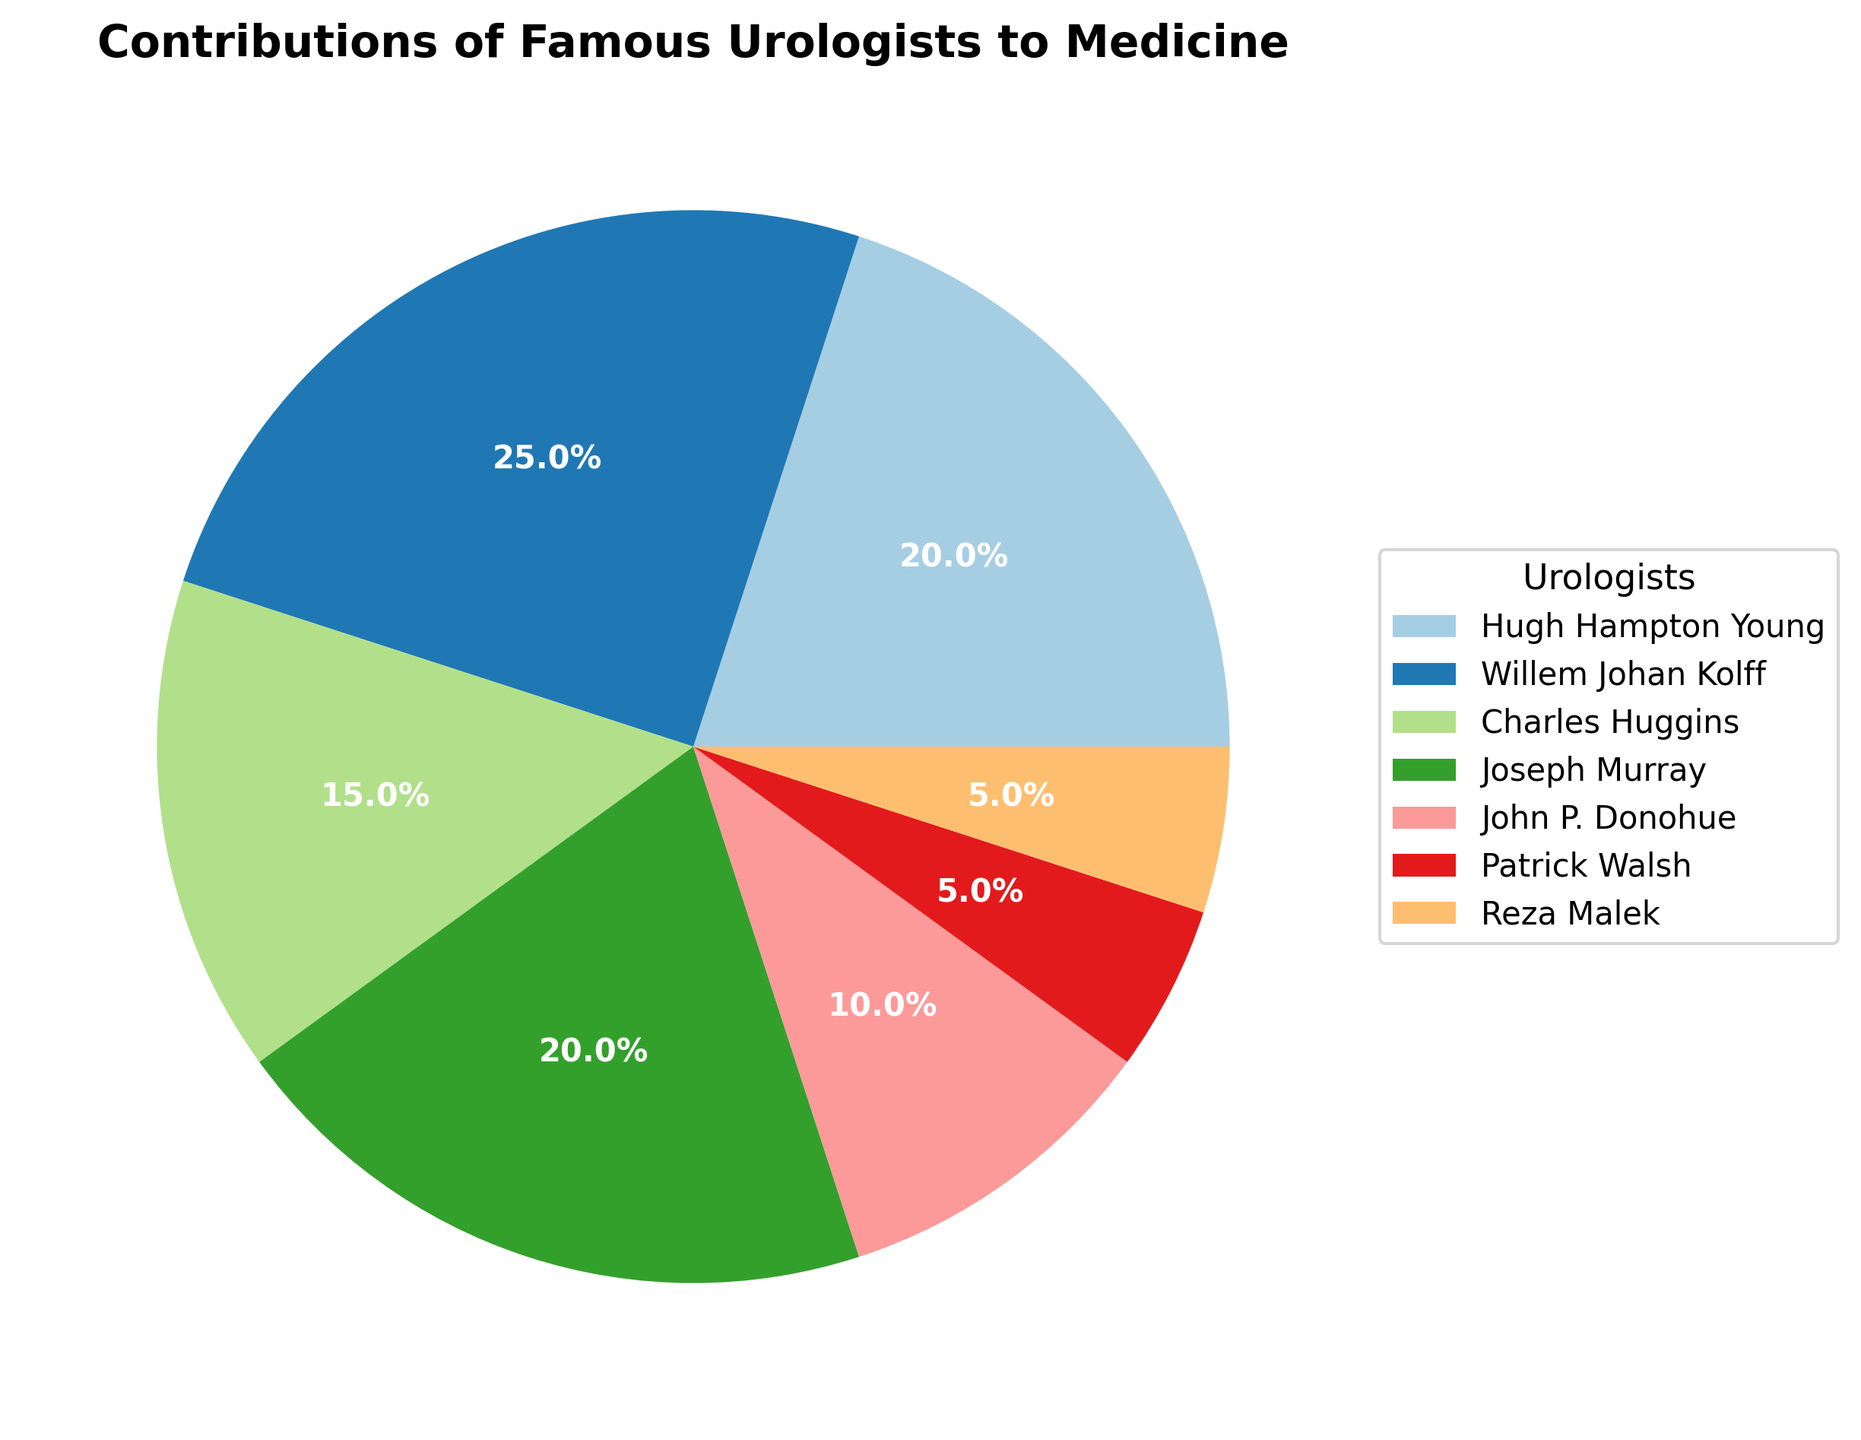What is the total percentage contribution of Hugh Hampton Young and Joseph Murray? To find the total percentage contribution, add the individual contributions of Hugh Hampton Young and Joseph Murray. Hugh Hampton Young's contribution is 20%, and Joseph Murray's contribution is also 20%. Adding them together gives 20% + 20% = 40%.
Answer: 40% Which urologist has made a greater contribution to medicine, Charles Huggins or John P. Donohue? Compare the percentages of contributions by Charles Huggins and John P. Donohue. Charles Huggins has a 15% contribution, while John P. Donohue has a 10% contribution. Since 15% is greater than 10%, Charles Huggins has made a greater contribution.
Answer: Charles Huggins What is the total contribution percentage of the urologists who worked on prostate surgery innovations and nerve-sparing prostatectomy? Add the percentages of contributions by Hugh Hampton Young (prostate surgery innovations) and Patrick Walsh (nerve-sparing prostatectomy). Hugh Hampton Young's contribution is 20%, and Patrick Walsh's is 5%. Therefore, the total contribution is 20% + 5% = 25%.
Answer: 25% Who has contributed more to medicine according to the pie chart, Willem Johan Kolff or the combined contributions of Patrick Walsh and Reza Malek? First, find the combined contributions of Patrick Walsh and Reza Malek, which are 5% + 5% = 10%. Compare this with Willem Johan Kolff's contribution, which is 25%. Since 25% is greater than 10%, Willem Johan Kolff has contributed more.
Answer: Willem Johan Kolff How much more significant is Willem Johan Kolff's contribution to medicine compared to Reza Malek's? Subtract Reza Malek's contribution percentage from Willem Johan Kolff's contribution percentage. Willem Johan Kolff's contribution is 25%, and Reza Malek's is 5%. The difference is 25% - 5% = 20%.
Answer: 20% If we combine the contributions of Hugh Hampton Young and Joseph Murray, what fraction of the total contributions does this combined percentage represent? First, find the combined contribution percentage of Hugh Hampton Young and Joseph Murray, which is 20% + 20% = 40%. Since the total contributions represented in the pie chart always sum to 100%, this combined contribution represents 40/100 = 2/5 or 40% of the total.
Answer: 2/5 Which visual attribute of the pie chart makes it easy to identify the largest contributor to medicine? The color segments in the pie chart make it easy to visually compare the sizes of each section, helping to identify Willem Johan Kolff as the largest contributor with 25%. These segments are distinguishable by their size and placement, which reflect the proportions accurately.
Answer: Color segments What is the difference in the percentage contributions between Charles Huggins and Patrick Walsh? Subtract Patrick Walsh's contribution percentage from Charles Huggins' contribution percentage. Charles Huggins' contribution is 15%, and Patrick Walsh's is 5%. The difference is 15% - 5% = 10%.
Answer: 10% Which two urologists have made an equal contribution to medicine, according to the pie chart? Look for urologists with the same percentage contribution. Both Hugh Hampton Young and Joseph Murray have each made a 20% contribution to medicine, making their contributions equal.
Answer: Hugh Hampton Young and Joseph Murray 